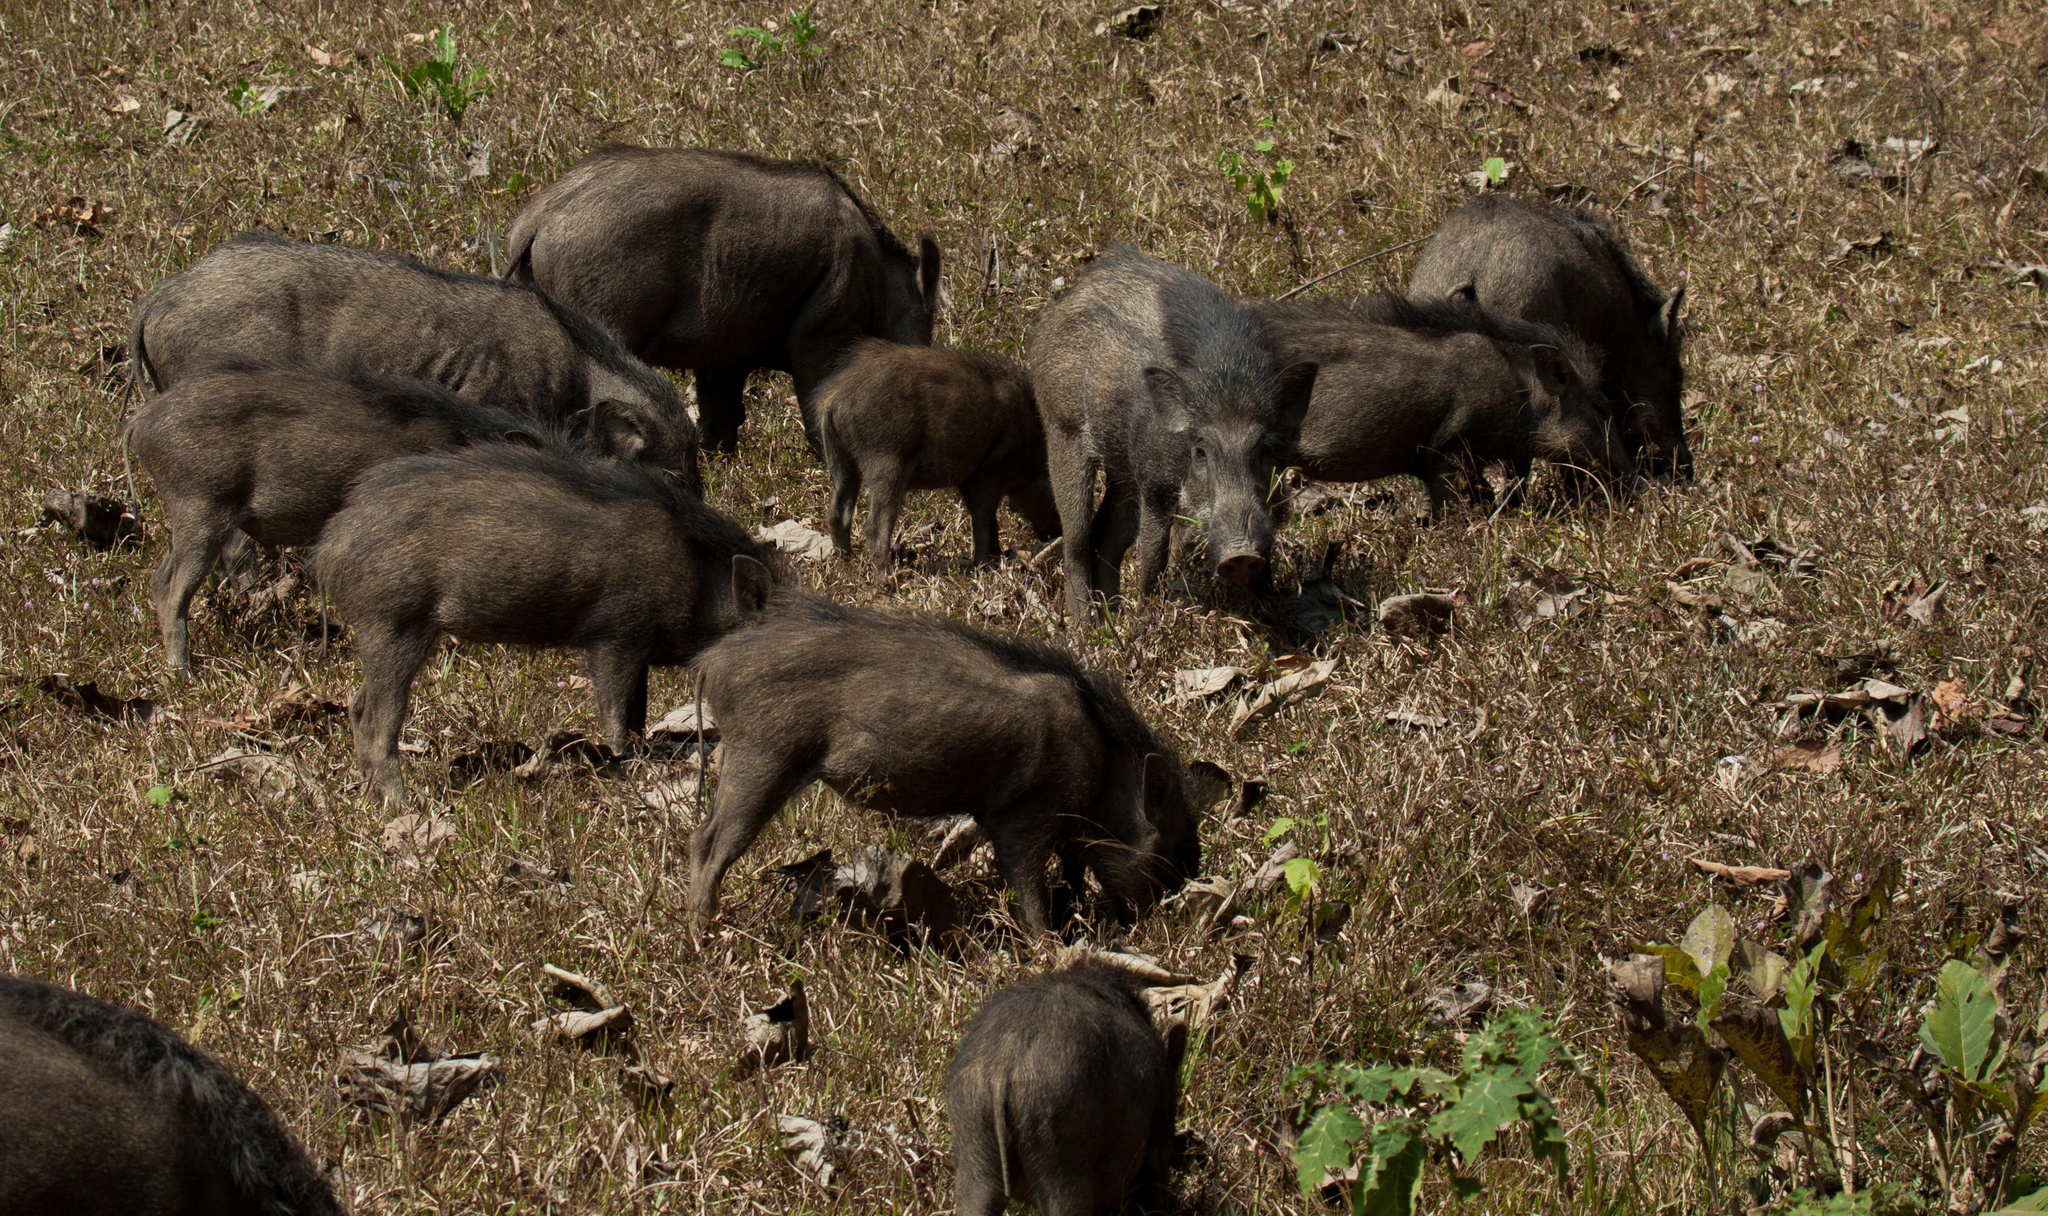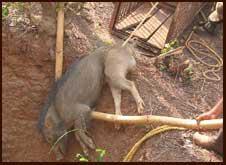The first image is the image on the left, the second image is the image on the right. For the images shown, is this caption "There are two wild pigs out in the wild." true? Answer yes or no. No. 